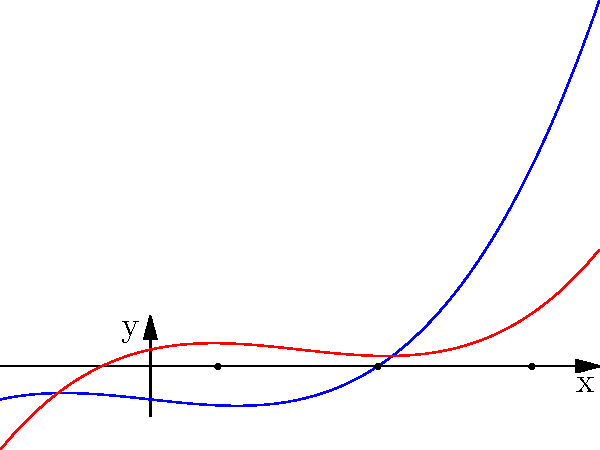Consider two polynomial functions $f(x) = x^3 - x - 2$ and $g(x) = x^3 - 3x^2 + 2x + 1$. You are tasked with implementing two root-finding algorithms: the Newton-Raphson method and the Bisection method. Based on the graph, which method would you recommend for finding the roots of $f(x)$, and which for $g(x)$? Justify your answer in terms of algorithmic efficiency and the nature of the functions. To determine the most efficient algorithm for each function, we need to analyze their characteristics:

1. For $f(x) = x^3 - x - 2$:
   - The graph shows a single root at approximately $x = 1.52$.
   - The function is monotonically increasing and has a relatively constant slope near the root.

2. For $g(x) = x^3 - 3x^2 + 2x + 1$:
   - The graph shows three roots at approximately $x = 0.45$, $x = 1$, and $x = 2.55$.
   - The function has areas of low slope between roots, particularly between $x = 1$ and $x = 2$.

Newton-Raphson method:
- Faster convergence when the initial guess is close to the root.
- Requires the function to be differentiable.
- Can struggle with areas of low slope or multiple nearby roots.

Bisection method:
- Guaranteed to converge if the root is bracketed.
- Slower convergence compared to Newton-Raphson in ideal conditions.
- Works well for functions with multiple roots or areas of low slope.

For $f(x)$:
The Newton-Raphson method would be more efficient due to the function's monotonic nature and consistent slope. The single root can be quickly approached with this method.

For $g(x)$:
The Bisection method would be more reliable due to the presence of multiple roots and areas of low slope. Newton-Raphson might struggle to converge in the flat regions between roots.

In terms of implementation, the Newton-Raphson method would require calculating derivatives, while the Bisection method only needs function evaluations. This makes the Bisection method simpler to implement but potentially slower in execution for well-behaved functions.
Answer: Newton-Raphson for $f(x)$, Bisection for $g(x)$ 